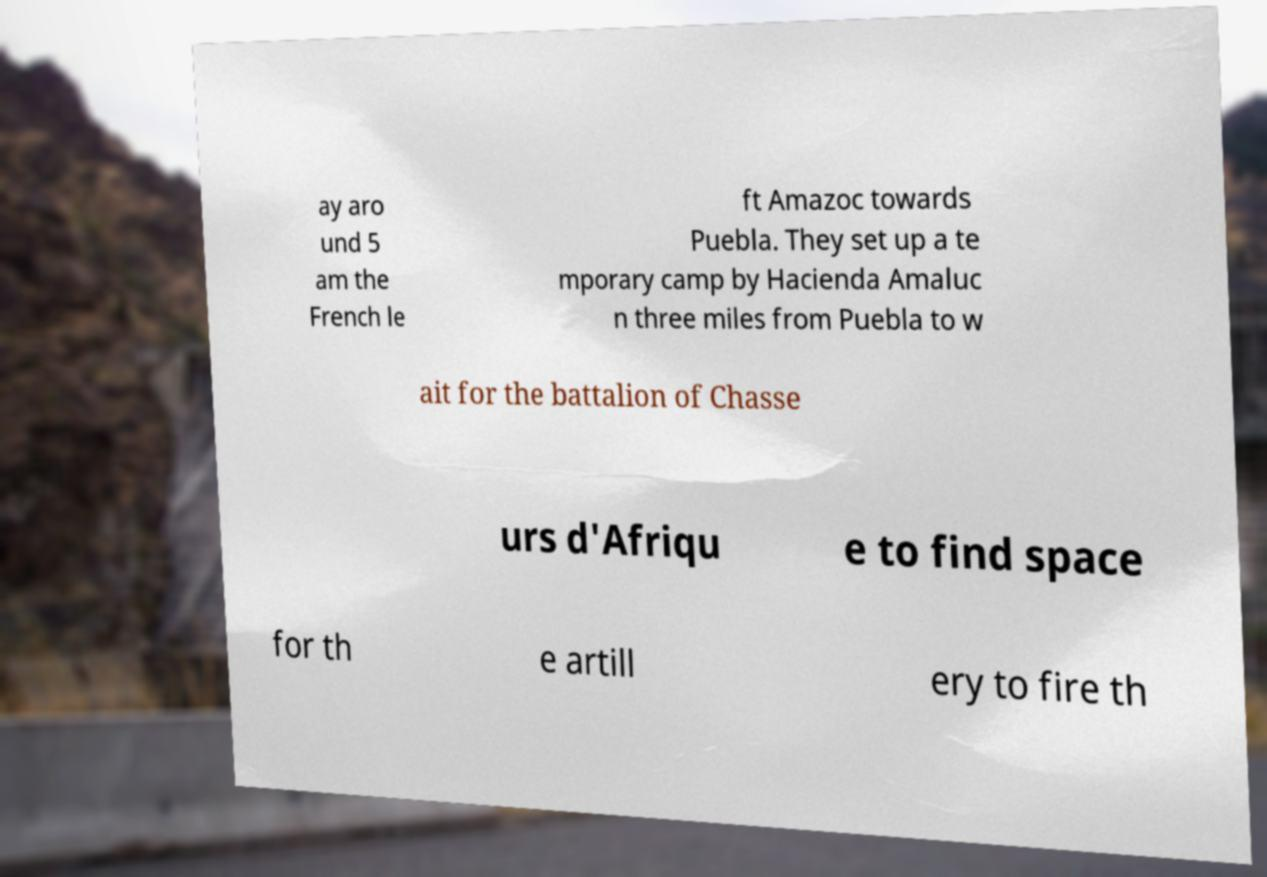What messages or text are displayed in this image? I need them in a readable, typed format. ay aro und 5 am the French le ft Amazoc towards Puebla. They set up a te mporary camp by Hacienda Amaluc n three miles from Puebla to w ait for the battalion of Chasse urs d'Afriqu e to find space for th e artill ery to fire th 